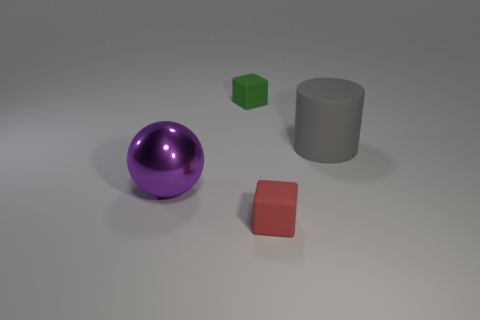There is a small object in front of the large rubber thing; is it the same shape as the large purple object? no 